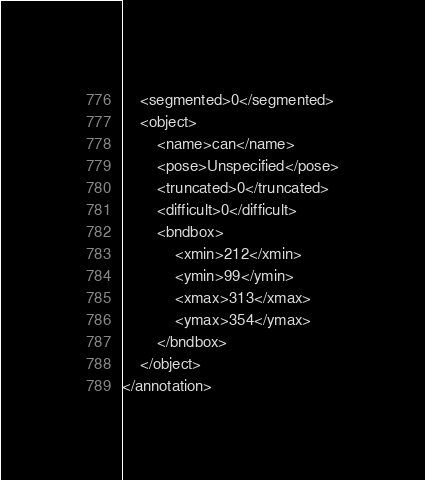<code> <loc_0><loc_0><loc_500><loc_500><_XML_>	<segmented>0</segmented>
	<object>
		<name>can</name>
		<pose>Unspecified</pose>
		<truncated>0</truncated>
		<difficult>0</difficult>
		<bndbox>
			<xmin>212</xmin>
			<ymin>99</ymin>
			<xmax>313</xmax>
			<ymax>354</ymax>
		</bndbox>
	</object>
</annotation>
</code> 